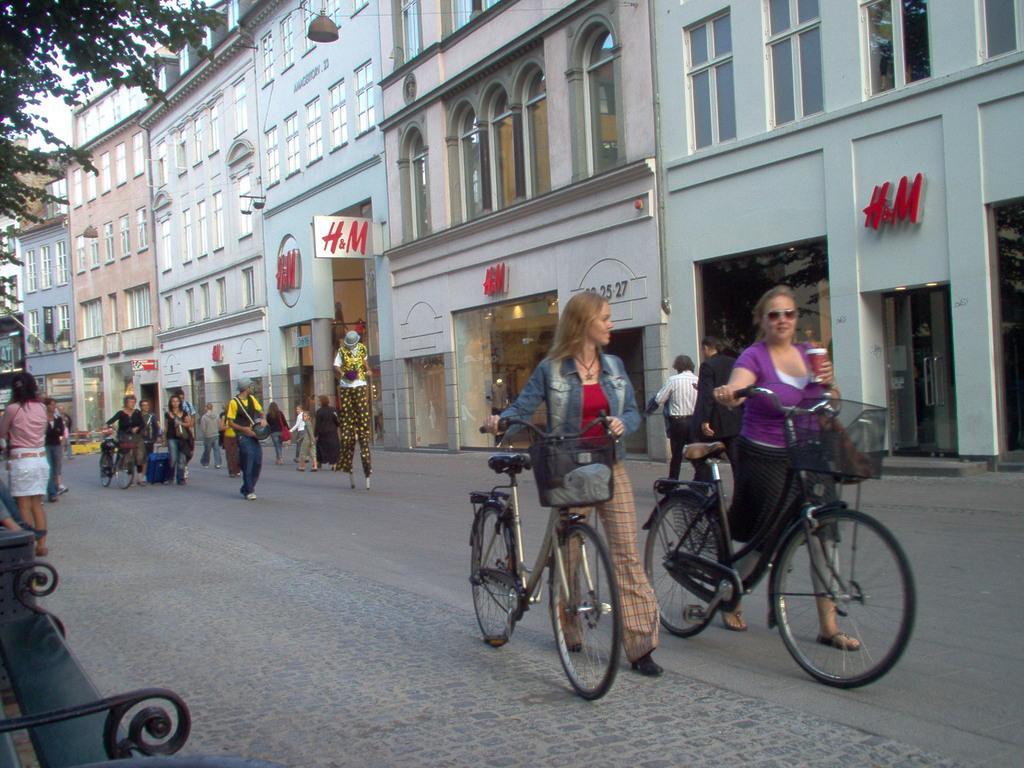Can you describe this image briefly? In this picture we can see buildings with windows and a store here. This is a tree. Here we can see persons walking on the road. We can see two women walking with bicycles near to the store. Here we can see bench. 